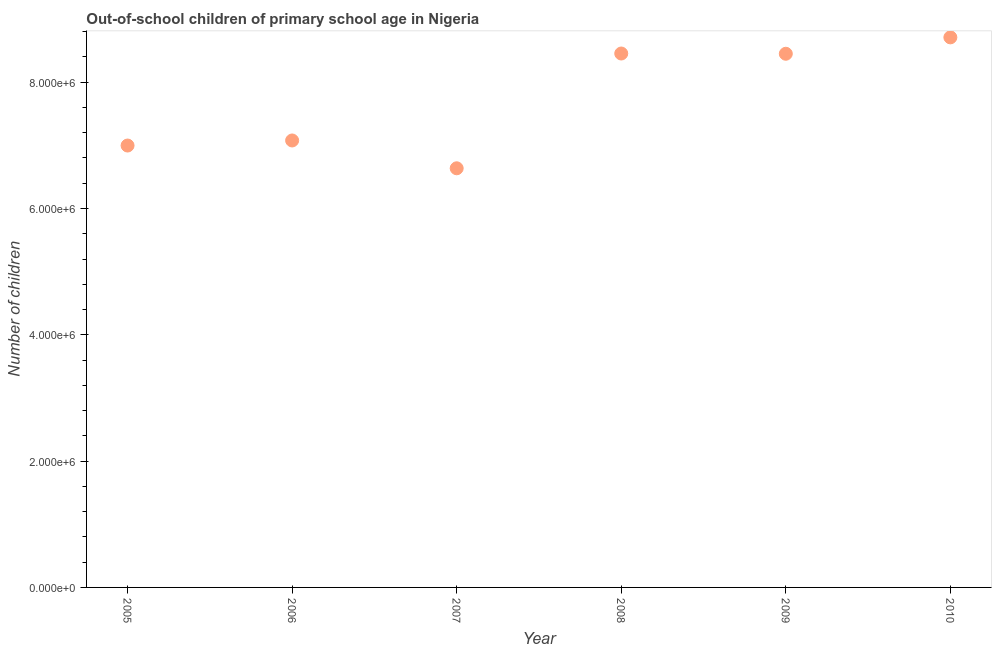What is the number of out-of-school children in 2010?
Your response must be concise. 8.71e+06. Across all years, what is the maximum number of out-of-school children?
Your response must be concise. 8.71e+06. Across all years, what is the minimum number of out-of-school children?
Keep it short and to the point. 6.64e+06. In which year was the number of out-of-school children maximum?
Give a very brief answer. 2010. In which year was the number of out-of-school children minimum?
Your answer should be very brief. 2007. What is the sum of the number of out-of-school children?
Keep it short and to the point. 4.63e+07. What is the difference between the number of out-of-school children in 2005 and 2008?
Your answer should be compact. -1.46e+06. What is the average number of out-of-school children per year?
Keep it short and to the point. 7.72e+06. What is the median number of out-of-school children?
Offer a very short reply. 7.76e+06. Do a majority of the years between 2007 and 2008 (inclusive) have number of out-of-school children greater than 4000000 ?
Ensure brevity in your answer.  Yes. What is the ratio of the number of out-of-school children in 2005 to that in 2009?
Ensure brevity in your answer.  0.83. Is the difference between the number of out-of-school children in 2007 and 2010 greater than the difference between any two years?
Offer a terse response. Yes. What is the difference between the highest and the second highest number of out-of-school children?
Make the answer very short. 2.56e+05. What is the difference between the highest and the lowest number of out-of-school children?
Make the answer very short. 2.07e+06. How many dotlines are there?
Provide a short and direct response. 1. How many years are there in the graph?
Give a very brief answer. 6. Are the values on the major ticks of Y-axis written in scientific E-notation?
Offer a very short reply. Yes. Does the graph contain any zero values?
Offer a very short reply. No. What is the title of the graph?
Ensure brevity in your answer.  Out-of-school children of primary school age in Nigeria. What is the label or title of the Y-axis?
Make the answer very short. Number of children. What is the Number of children in 2005?
Offer a very short reply. 7.00e+06. What is the Number of children in 2006?
Provide a short and direct response. 7.08e+06. What is the Number of children in 2007?
Provide a succinct answer. 6.64e+06. What is the Number of children in 2008?
Make the answer very short. 8.45e+06. What is the Number of children in 2009?
Provide a short and direct response. 8.45e+06. What is the Number of children in 2010?
Ensure brevity in your answer.  8.71e+06. What is the difference between the Number of children in 2005 and 2006?
Your response must be concise. -8.01e+04. What is the difference between the Number of children in 2005 and 2007?
Provide a succinct answer. 3.60e+05. What is the difference between the Number of children in 2005 and 2008?
Your response must be concise. -1.46e+06. What is the difference between the Number of children in 2005 and 2009?
Provide a succinct answer. -1.45e+06. What is the difference between the Number of children in 2005 and 2010?
Provide a short and direct response. -1.71e+06. What is the difference between the Number of children in 2006 and 2007?
Your response must be concise. 4.40e+05. What is the difference between the Number of children in 2006 and 2008?
Ensure brevity in your answer.  -1.38e+06. What is the difference between the Number of children in 2006 and 2009?
Keep it short and to the point. -1.37e+06. What is the difference between the Number of children in 2006 and 2010?
Make the answer very short. -1.63e+06. What is the difference between the Number of children in 2007 and 2008?
Your answer should be compact. -1.82e+06. What is the difference between the Number of children in 2007 and 2009?
Ensure brevity in your answer.  -1.81e+06. What is the difference between the Number of children in 2007 and 2010?
Your answer should be very brief. -2.07e+06. What is the difference between the Number of children in 2008 and 2009?
Your response must be concise. 3838. What is the difference between the Number of children in 2008 and 2010?
Provide a succinct answer. -2.56e+05. What is the difference between the Number of children in 2009 and 2010?
Provide a succinct answer. -2.59e+05. What is the ratio of the Number of children in 2005 to that in 2007?
Provide a succinct answer. 1.05. What is the ratio of the Number of children in 2005 to that in 2008?
Your answer should be compact. 0.83. What is the ratio of the Number of children in 2005 to that in 2009?
Your answer should be compact. 0.83. What is the ratio of the Number of children in 2005 to that in 2010?
Your response must be concise. 0.8. What is the ratio of the Number of children in 2006 to that in 2007?
Make the answer very short. 1.07. What is the ratio of the Number of children in 2006 to that in 2008?
Make the answer very short. 0.84. What is the ratio of the Number of children in 2006 to that in 2009?
Provide a short and direct response. 0.84. What is the ratio of the Number of children in 2006 to that in 2010?
Provide a succinct answer. 0.81. What is the ratio of the Number of children in 2007 to that in 2008?
Ensure brevity in your answer.  0.79. What is the ratio of the Number of children in 2007 to that in 2009?
Provide a succinct answer. 0.79. What is the ratio of the Number of children in 2007 to that in 2010?
Your answer should be very brief. 0.76. What is the ratio of the Number of children in 2008 to that in 2009?
Your answer should be compact. 1. 